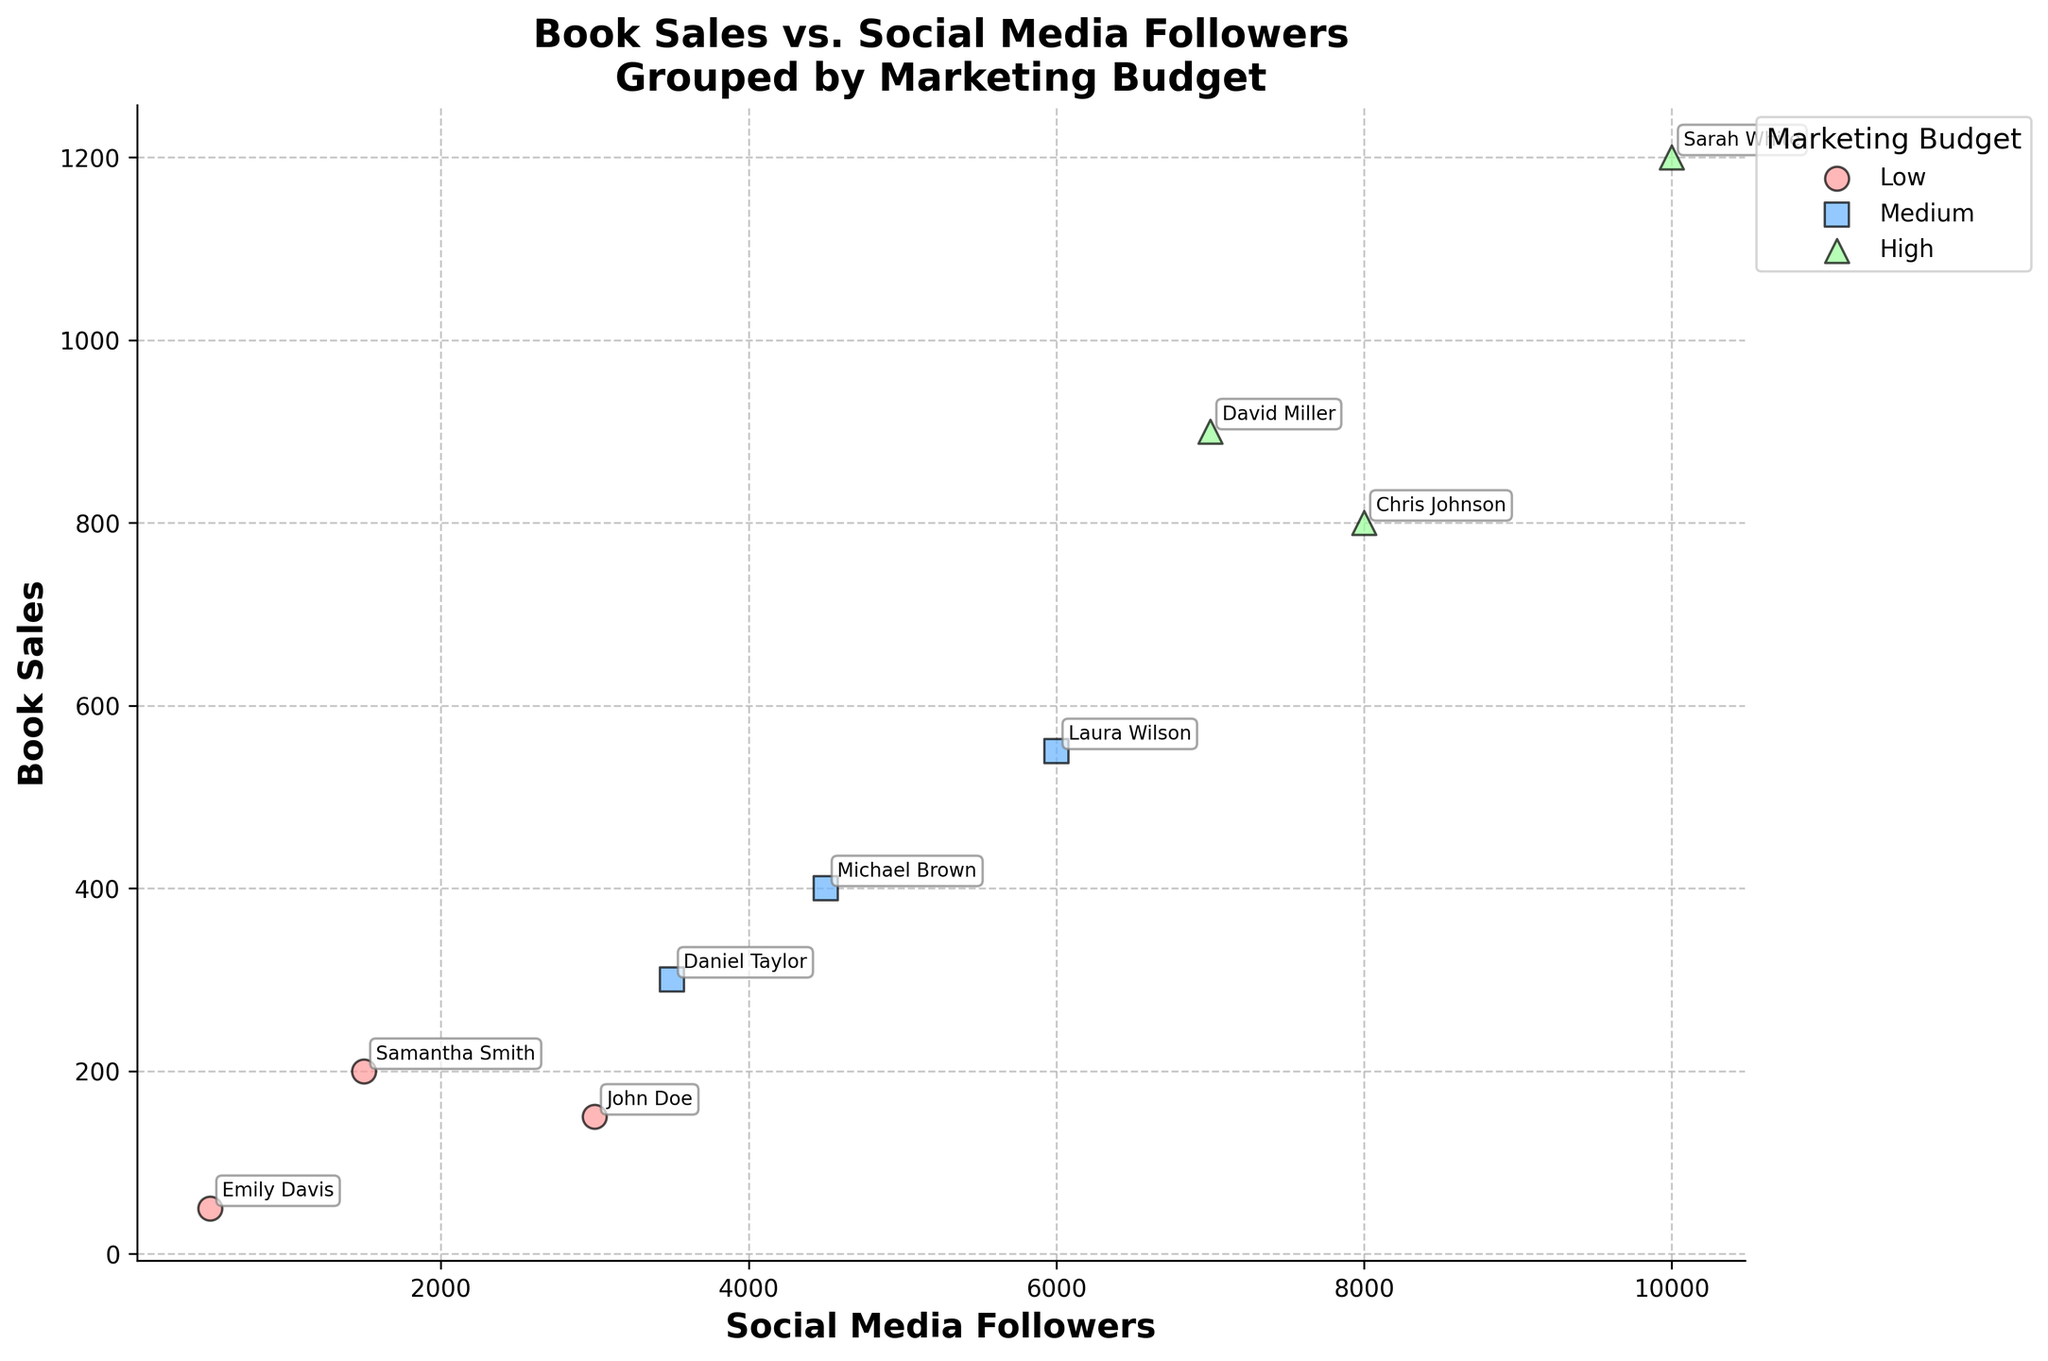What is the title of the plot? The title of the plot is positioned at the top and usually describes what the plot is about. From the given information, the title is clear.
Answer: Book Sales vs. Social Media Followers Grouped by Marketing Budget How many marketing budget levels are presented in the plot? By observing the legend, we can identify the distinct groups represented by different colors/markers which correspond to different budget levels.
Answer: Three Which marketing budget level has the highest sales recorded? Look for the group of points in the plot with the highest y-value. This data point should correspond to a specific budget level.
Answer: High Which author has the lowest book sales? Find the data point with the smallest y-value and identify the author's name associated with this point.
Answer: Emily Davis What is the relationship between social media followers and book sales for authors with a high marketing budget? Observe the scatter points labeled with high marketing budget and see if there is any pattern or trend in their distribution.
Answer: Positive relationship Which author has the highest number of social media followers among the medium marketing budget group? Check the scatter points for the medium marketing budget group and identify the one with the highest x-value, then note the author's name.
Answer: Laura Wilson What is the difference in book sales between Chris Johnson and Sarah White? Find the book sales for both authors, then subtract the smaller value from the larger one to calculate the difference. Chris Johnson has 800 sales and Sarah White has 1200 sales. The difference is 1200 - 800.
Answer: 400 On average, how many book sales do authors with low marketing budgets have? Sum the book sales for authors with low marketing budgets and divide by the number of authors in this group. The sum is 200 + 150 + 50 = 400, and there are 3 authors, so the average is 400 / 3.
Answer: 133 How does the book sale trend differ between low and high marketing budget levels? Compare the scatter points for low and high marketing budget groups to observe the general trend in book sales against social media followers.
Answer: Low budget has fewer sales overall, while high budget shows higher sales Which marketing budget level has more variability in social media followers? Look at the spread of social media followers (x-axis) for each budget level and see which one has the widest range (minimum to maximum).
Answer: Medium 